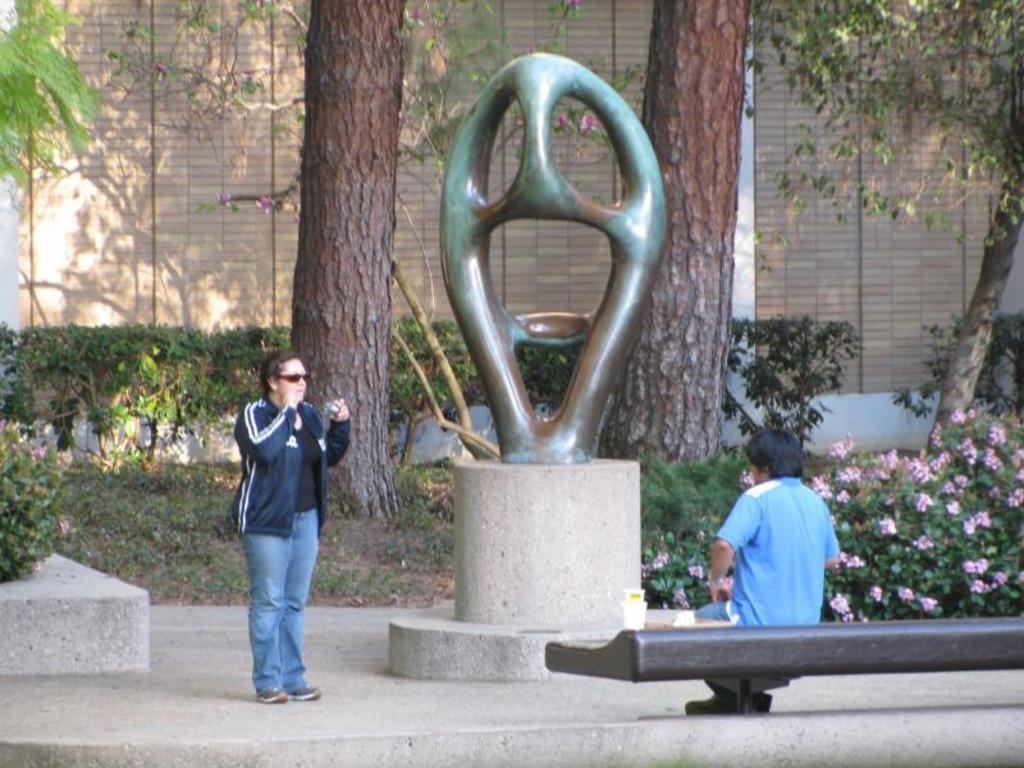Could you give a brief overview of what you see in this image? In this image we can see two persons, among them one person is sitting on the bench and the other person is standing and holding an object, also we can see a statue, there are some trees, flowers, plants, grass and the wall. 